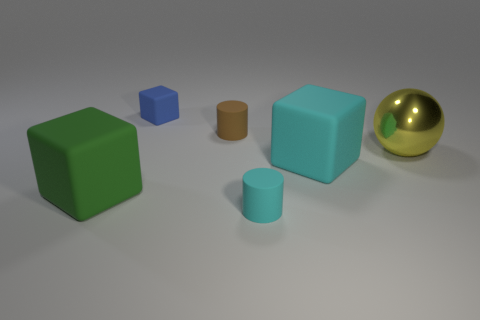Add 3 yellow spheres. How many objects exist? 9 Subtract all balls. How many objects are left? 5 Add 6 small blue cylinders. How many small blue cylinders exist? 6 Subtract 0 purple balls. How many objects are left? 6 Subtract all spheres. Subtract all small brown matte things. How many objects are left? 4 Add 1 small brown rubber cylinders. How many small brown rubber cylinders are left? 2 